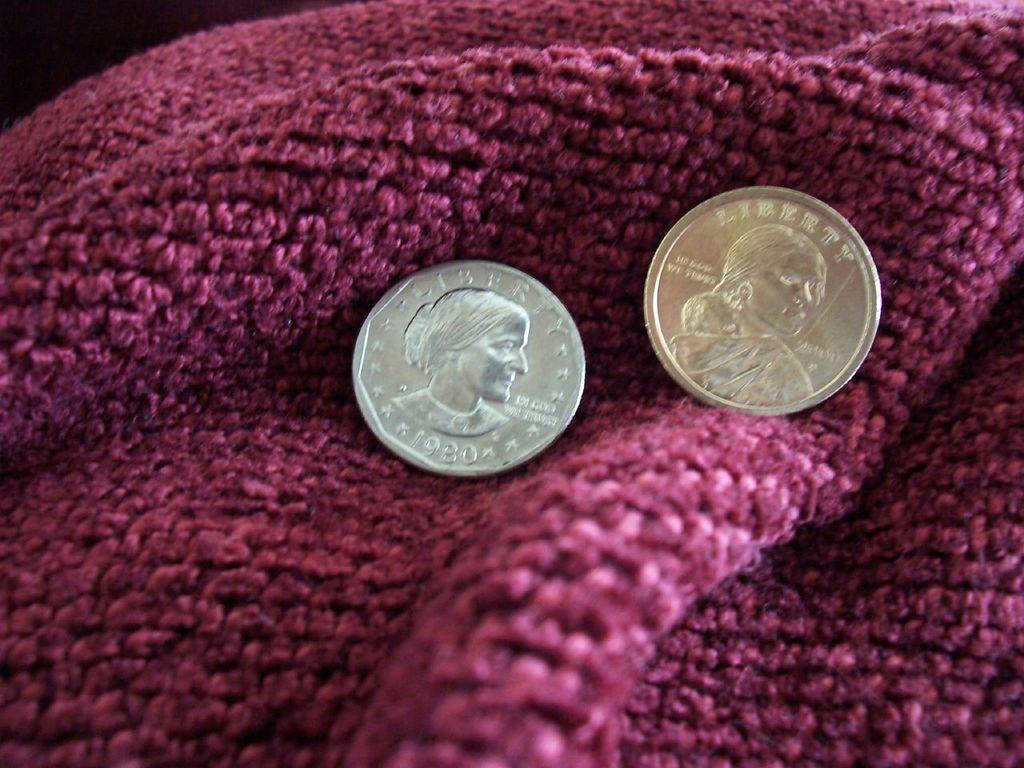<image>
Create a compact narrative representing the image presented. Two coins with the word Liberty written on them are displayed on a red blanket. 